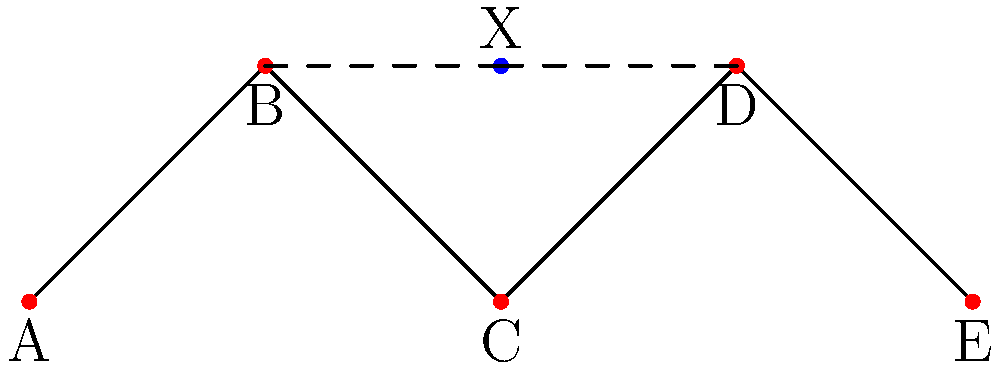In a mesh network topology, nodes A, B, C, D, and E are placed as shown. To optimize network performance, a new node X needs to be added. If the goal is to minimize the maximum distance between X and its two nearest neighbors, what are the coordinates of the optimal placement for X? To solve this problem, we'll follow these steps:

1) Observe that the optimal placement of X should be equidistant from its two nearest neighbors to minimize the maximum distance.

2) The two nearest neighbors will be the two nodes at y=1, which are B(1,1) and D(3,1).

3) The optimal position for X will be at the midpoint between B and D:

   $x_{optimal} = \frac{x_B + x_D}{2} = \frac{1 + 3}{2} = 2$
   $y_{optimal} = y_B = y_D = 1$

4) Therefore, the optimal coordinates for X are (2,1).

5) We can verify that this placement minimizes the maximum distance:
   - Distance from X to B: $\sqrt{(2-1)^2 + (1-1)^2} = 1$
   - Distance from X to D: $\sqrt{(2-3)^2 + (1-1)^2} = 1$

   The maximum distance to the nearest neighbors is 1, which is the minimum possible in this configuration.
Answer: (2,1) 